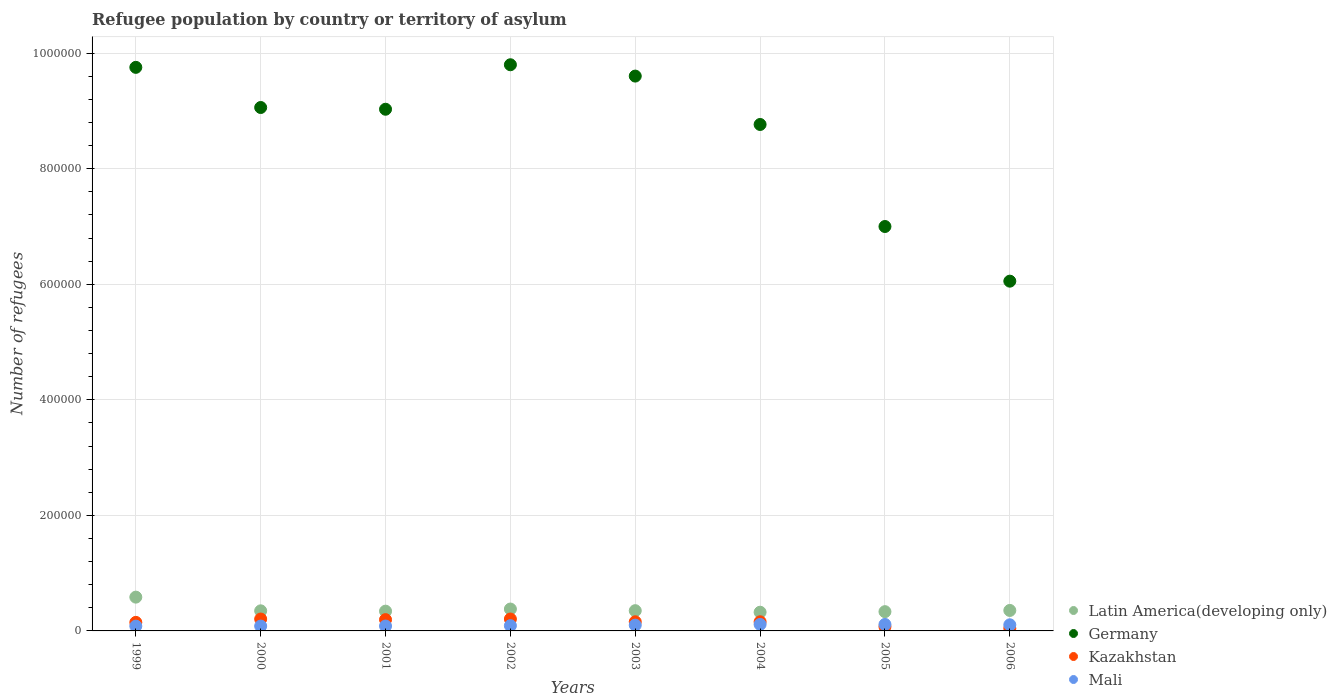How many different coloured dotlines are there?
Offer a very short reply. 4. What is the number of refugees in Germany in 2001?
Your answer should be compact. 9.03e+05. Across all years, what is the maximum number of refugees in Germany?
Your answer should be very brief. 9.80e+05. Across all years, what is the minimum number of refugees in Mali?
Ensure brevity in your answer.  8302. In which year was the number of refugees in Germany maximum?
Offer a very short reply. 2002. In which year was the number of refugees in Kazakhstan minimum?
Make the answer very short. 2006. What is the total number of refugees in Mali in the graph?
Keep it short and to the point. 7.73e+04. What is the difference between the number of refugees in Kazakhstan in 1999 and that in 2005?
Your answer should be very brief. 7530. What is the difference between the number of refugees in Latin America(developing only) in 2004 and the number of refugees in Germany in 2005?
Offer a very short reply. -6.68e+05. What is the average number of refugees in Kazakhstan per year?
Your answer should be very brief. 1.49e+04. In the year 2005, what is the difference between the number of refugees in Kazakhstan and number of refugees in Germany?
Provide a succinct answer. -6.93e+05. In how many years, is the number of refugees in Latin America(developing only) greater than 720000?
Your response must be concise. 0. What is the ratio of the number of refugees in Latin America(developing only) in 2002 to that in 2006?
Offer a terse response. 1.07. Is the number of refugees in Mali in 2002 less than that in 2006?
Ensure brevity in your answer.  Yes. Is the difference between the number of refugees in Kazakhstan in 1999 and 2006 greater than the difference between the number of refugees in Germany in 1999 and 2006?
Keep it short and to the point. No. What is the difference between the highest and the second highest number of refugees in Latin America(developing only)?
Provide a short and direct response. 2.06e+04. What is the difference between the highest and the lowest number of refugees in Germany?
Offer a terse response. 3.75e+05. Is it the case that in every year, the sum of the number of refugees in Germany and number of refugees in Mali  is greater than the sum of number of refugees in Kazakhstan and number of refugees in Latin America(developing only)?
Your answer should be compact. No. Is it the case that in every year, the sum of the number of refugees in Mali and number of refugees in Germany  is greater than the number of refugees in Latin America(developing only)?
Your answer should be compact. Yes. Does the number of refugees in Mali monotonically increase over the years?
Provide a succinct answer. No. Is the number of refugees in Latin America(developing only) strictly less than the number of refugees in Kazakhstan over the years?
Your answer should be compact. No. What is the difference between two consecutive major ticks on the Y-axis?
Provide a short and direct response. 2.00e+05. Are the values on the major ticks of Y-axis written in scientific E-notation?
Offer a terse response. No. How many legend labels are there?
Ensure brevity in your answer.  4. What is the title of the graph?
Provide a succinct answer. Refugee population by country or territory of asylum. Does "St. Kitts and Nevis" appear as one of the legend labels in the graph?
Ensure brevity in your answer.  No. What is the label or title of the X-axis?
Provide a succinct answer. Years. What is the label or title of the Y-axis?
Provide a succinct answer. Number of refugees. What is the Number of refugees of Latin America(developing only) in 1999?
Your response must be concise. 5.85e+04. What is the Number of refugees in Germany in 1999?
Provide a succinct answer. 9.76e+05. What is the Number of refugees of Kazakhstan in 1999?
Give a very brief answer. 1.48e+04. What is the Number of refugees of Mali in 1999?
Provide a succinct answer. 8302. What is the Number of refugees of Latin America(developing only) in 2000?
Your answer should be very brief. 3.48e+04. What is the Number of refugees of Germany in 2000?
Your answer should be compact. 9.06e+05. What is the Number of refugees in Kazakhstan in 2000?
Make the answer very short. 2.06e+04. What is the Number of refugees of Mali in 2000?
Offer a very short reply. 8412. What is the Number of refugees of Latin America(developing only) in 2001?
Ensure brevity in your answer.  3.42e+04. What is the Number of refugees of Germany in 2001?
Offer a very short reply. 9.03e+05. What is the Number of refugees of Kazakhstan in 2001?
Your answer should be compact. 1.95e+04. What is the Number of refugees in Mali in 2001?
Your response must be concise. 8439. What is the Number of refugees in Latin America(developing only) in 2002?
Your answer should be very brief. 3.79e+04. What is the Number of refugees in Germany in 2002?
Offer a very short reply. 9.80e+05. What is the Number of refugees in Kazakhstan in 2002?
Offer a very short reply. 2.06e+04. What is the Number of refugees of Mali in 2002?
Keep it short and to the point. 9095. What is the Number of refugees of Latin America(developing only) in 2003?
Provide a short and direct response. 3.50e+04. What is the Number of refugees of Germany in 2003?
Ensure brevity in your answer.  9.60e+05. What is the Number of refugees of Kazakhstan in 2003?
Provide a short and direct response. 1.58e+04. What is the Number of refugees in Mali in 2003?
Your answer should be very brief. 1.00e+04. What is the Number of refugees of Latin America(developing only) in 2004?
Keep it short and to the point. 3.24e+04. What is the Number of refugees of Germany in 2004?
Offer a terse response. 8.77e+05. What is the Number of refugees in Kazakhstan in 2004?
Keep it short and to the point. 1.58e+04. What is the Number of refugees in Mali in 2004?
Provide a short and direct response. 1.13e+04. What is the Number of refugees of Latin America(developing only) in 2005?
Give a very brief answer. 3.33e+04. What is the Number of refugees in Germany in 2005?
Ensure brevity in your answer.  7.00e+05. What is the Number of refugees in Kazakhstan in 2005?
Offer a very short reply. 7265. What is the Number of refugees in Mali in 2005?
Make the answer very short. 1.12e+04. What is the Number of refugees in Latin America(developing only) in 2006?
Make the answer very short. 3.54e+04. What is the Number of refugees in Germany in 2006?
Offer a terse response. 6.05e+05. What is the Number of refugees of Kazakhstan in 2006?
Provide a succinct answer. 4412. What is the Number of refugees in Mali in 2006?
Your answer should be compact. 1.06e+04. Across all years, what is the maximum Number of refugees of Latin America(developing only)?
Offer a terse response. 5.85e+04. Across all years, what is the maximum Number of refugees in Germany?
Provide a succinct answer. 9.80e+05. Across all years, what is the maximum Number of refugees of Kazakhstan?
Your answer should be compact. 2.06e+04. Across all years, what is the maximum Number of refugees in Mali?
Make the answer very short. 1.13e+04. Across all years, what is the minimum Number of refugees of Latin America(developing only)?
Provide a short and direct response. 3.24e+04. Across all years, what is the minimum Number of refugees of Germany?
Your answer should be compact. 6.05e+05. Across all years, what is the minimum Number of refugees in Kazakhstan?
Provide a succinct answer. 4412. Across all years, what is the minimum Number of refugees in Mali?
Offer a terse response. 8302. What is the total Number of refugees in Latin America(developing only) in the graph?
Keep it short and to the point. 3.02e+05. What is the total Number of refugees in Germany in the graph?
Ensure brevity in your answer.  6.91e+06. What is the total Number of refugees of Kazakhstan in the graph?
Provide a short and direct response. 1.19e+05. What is the total Number of refugees of Mali in the graph?
Give a very brief answer. 7.73e+04. What is the difference between the Number of refugees of Latin America(developing only) in 1999 and that in 2000?
Keep it short and to the point. 2.37e+04. What is the difference between the Number of refugees of Germany in 1999 and that in 2000?
Provide a succinct answer. 6.95e+04. What is the difference between the Number of refugees in Kazakhstan in 1999 and that in 2000?
Your response must be concise. -5779. What is the difference between the Number of refugees of Mali in 1999 and that in 2000?
Your answer should be compact. -110. What is the difference between the Number of refugees in Latin America(developing only) in 1999 and that in 2001?
Give a very brief answer. 2.43e+04. What is the difference between the Number of refugees in Germany in 1999 and that in 2001?
Offer a very short reply. 7.25e+04. What is the difference between the Number of refugees of Kazakhstan in 1999 and that in 2001?
Make the answer very short. -4736. What is the difference between the Number of refugees in Mali in 1999 and that in 2001?
Provide a short and direct response. -137. What is the difference between the Number of refugees in Latin America(developing only) in 1999 and that in 2002?
Provide a short and direct response. 2.06e+04. What is the difference between the Number of refugees in Germany in 1999 and that in 2002?
Give a very brief answer. -4500. What is the difference between the Number of refugees in Kazakhstan in 1999 and that in 2002?
Make the answer very short. -5815. What is the difference between the Number of refugees of Mali in 1999 and that in 2002?
Provide a short and direct response. -793. What is the difference between the Number of refugees in Latin America(developing only) in 1999 and that in 2003?
Ensure brevity in your answer.  2.34e+04. What is the difference between the Number of refugees of Germany in 1999 and that in 2003?
Offer a terse response. 1.51e+04. What is the difference between the Number of refugees of Kazakhstan in 1999 and that in 2003?
Your answer should be compact. -1036. What is the difference between the Number of refugees in Mali in 1999 and that in 2003?
Your answer should be compact. -1707. What is the difference between the Number of refugees of Latin America(developing only) in 1999 and that in 2004?
Make the answer very short. 2.61e+04. What is the difference between the Number of refugees of Germany in 1999 and that in 2004?
Keep it short and to the point. 9.89e+04. What is the difference between the Number of refugees in Kazakhstan in 1999 and that in 2004?
Your response must be concise. -1049. What is the difference between the Number of refugees of Mali in 1999 and that in 2004?
Your answer should be compact. -2954. What is the difference between the Number of refugees of Latin America(developing only) in 1999 and that in 2005?
Provide a short and direct response. 2.51e+04. What is the difference between the Number of refugees in Germany in 1999 and that in 2005?
Offer a very short reply. 2.75e+05. What is the difference between the Number of refugees in Kazakhstan in 1999 and that in 2005?
Offer a terse response. 7530. What is the difference between the Number of refugees in Mali in 1999 and that in 2005?
Your answer should be very brief. -2931. What is the difference between the Number of refugees of Latin America(developing only) in 1999 and that in 2006?
Make the answer very short. 2.30e+04. What is the difference between the Number of refugees in Germany in 1999 and that in 2006?
Your response must be concise. 3.70e+05. What is the difference between the Number of refugees in Kazakhstan in 1999 and that in 2006?
Keep it short and to the point. 1.04e+04. What is the difference between the Number of refugees in Mali in 1999 and that in 2006?
Offer a very short reply. -2283. What is the difference between the Number of refugees of Latin America(developing only) in 2000 and that in 2001?
Offer a terse response. 583. What is the difference between the Number of refugees in Germany in 2000 and that in 2001?
Provide a short and direct response. 3000. What is the difference between the Number of refugees in Kazakhstan in 2000 and that in 2001?
Provide a succinct answer. 1043. What is the difference between the Number of refugees of Latin America(developing only) in 2000 and that in 2002?
Provide a short and direct response. -3089. What is the difference between the Number of refugees in Germany in 2000 and that in 2002?
Ensure brevity in your answer.  -7.40e+04. What is the difference between the Number of refugees in Kazakhstan in 2000 and that in 2002?
Give a very brief answer. -36. What is the difference between the Number of refugees in Mali in 2000 and that in 2002?
Make the answer very short. -683. What is the difference between the Number of refugees of Latin America(developing only) in 2000 and that in 2003?
Give a very brief answer. -262. What is the difference between the Number of refugees in Germany in 2000 and that in 2003?
Your answer should be very brief. -5.44e+04. What is the difference between the Number of refugees in Kazakhstan in 2000 and that in 2003?
Keep it short and to the point. 4743. What is the difference between the Number of refugees of Mali in 2000 and that in 2003?
Offer a very short reply. -1597. What is the difference between the Number of refugees in Latin America(developing only) in 2000 and that in 2004?
Your response must be concise. 2416. What is the difference between the Number of refugees of Germany in 2000 and that in 2004?
Offer a very short reply. 2.94e+04. What is the difference between the Number of refugees of Kazakhstan in 2000 and that in 2004?
Keep it short and to the point. 4730. What is the difference between the Number of refugees of Mali in 2000 and that in 2004?
Your response must be concise. -2844. What is the difference between the Number of refugees of Latin America(developing only) in 2000 and that in 2005?
Make the answer very short. 1440. What is the difference between the Number of refugees of Germany in 2000 and that in 2005?
Provide a succinct answer. 2.06e+05. What is the difference between the Number of refugees of Kazakhstan in 2000 and that in 2005?
Your answer should be compact. 1.33e+04. What is the difference between the Number of refugees of Mali in 2000 and that in 2005?
Your response must be concise. -2821. What is the difference between the Number of refugees of Latin America(developing only) in 2000 and that in 2006?
Offer a terse response. -660. What is the difference between the Number of refugees in Germany in 2000 and that in 2006?
Make the answer very short. 3.01e+05. What is the difference between the Number of refugees in Kazakhstan in 2000 and that in 2006?
Provide a succinct answer. 1.62e+04. What is the difference between the Number of refugees in Mali in 2000 and that in 2006?
Keep it short and to the point. -2173. What is the difference between the Number of refugees of Latin America(developing only) in 2001 and that in 2002?
Keep it short and to the point. -3672. What is the difference between the Number of refugees in Germany in 2001 and that in 2002?
Provide a succinct answer. -7.70e+04. What is the difference between the Number of refugees of Kazakhstan in 2001 and that in 2002?
Your answer should be very brief. -1079. What is the difference between the Number of refugees in Mali in 2001 and that in 2002?
Give a very brief answer. -656. What is the difference between the Number of refugees of Latin America(developing only) in 2001 and that in 2003?
Make the answer very short. -845. What is the difference between the Number of refugees of Germany in 2001 and that in 2003?
Your answer should be compact. -5.74e+04. What is the difference between the Number of refugees of Kazakhstan in 2001 and that in 2003?
Keep it short and to the point. 3700. What is the difference between the Number of refugees of Mali in 2001 and that in 2003?
Offer a very short reply. -1570. What is the difference between the Number of refugees in Latin America(developing only) in 2001 and that in 2004?
Provide a short and direct response. 1833. What is the difference between the Number of refugees in Germany in 2001 and that in 2004?
Offer a very short reply. 2.64e+04. What is the difference between the Number of refugees in Kazakhstan in 2001 and that in 2004?
Provide a succinct answer. 3687. What is the difference between the Number of refugees of Mali in 2001 and that in 2004?
Your response must be concise. -2817. What is the difference between the Number of refugees of Latin America(developing only) in 2001 and that in 2005?
Offer a terse response. 857. What is the difference between the Number of refugees of Germany in 2001 and that in 2005?
Your answer should be compact. 2.03e+05. What is the difference between the Number of refugees of Kazakhstan in 2001 and that in 2005?
Ensure brevity in your answer.  1.23e+04. What is the difference between the Number of refugees of Mali in 2001 and that in 2005?
Keep it short and to the point. -2794. What is the difference between the Number of refugees of Latin America(developing only) in 2001 and that in 2006?
Ensure brevity in your answer.  -1243. What is the difference between the Number of refugees in Germany in 2001 and that in 2006?
Make the answer very short. 2.98e+05. What is the difference between the Number of refugees in Kazakhstan in 2001 and that in 2006?
Your response must be concise. 1.51e+04. What is the difference between the Number of refugees in Mali in 2001 and that in 2006?
Provide a succinct answer. -2146. What is the difference between the Number of refugees in Latin America(developing only) in 2002 and that in 2003?
Offer a terse response. 2827. What is the difference between the Number of refugees of Germany in 2002 and that in 2003?
Your answer should be compact. 1.96e+04. What is the difference between the Number of refugees in Kazakhstan in 2002 and that in 2003?
Provide a short and direct response. 4779. What is the difference between the Number of refugees in Mali in 2002 and that in 2003?
Provide a succinct answer. -914. What is the difference between the Number of refugees of Latin America(developing only) in 2002 and that in 2004?
Ensure brevity in your answer.  5505. What is the difference between the Number of refugees in Germany in 2002 and that in 2004?
Provide a short and direct response. 1.03e+05. What is the difference between the Number of refugees of Kazakhstan in 2002 and that in 2004?
Provide a short and direct response. 4766. What is the difference between the Number of refugees of Mali in 2002 and that in 2004?
Your answer should be very brief. -2161. What is the difference between the Number of refugees of Latin America(developing only) in 2002 and that in 2005?
Your response must be concise. 4529. What is the difference between the Number of refugees in Germany in 2002 and that in 2005?
Ensure brevity in your answer.  2.80e+05. What is the difference between the Number of refugees in Kazakhstan in 2002 and that in 2005?
Make the answer very short. 1.33e+04. What is the difference between the Number of refugees of Mali in 2002 and that in 2005?
Provide a short and direct response. -2138. What is the difference between the Number of refugees in Latin America(developing only) in 2002 and that in 2006?
Offer a terse response. 2429. What is the difference between the Number of refugees in Germany in 2002 and that in 2006?
Ensure brevity in your answer.  3.75e+05. What is the difference between the Number of refugees in Kazakhstan in 2002 and that in 2006?
Provide a short and direct response. 1.62e+04. What is the difference between the Number of refugees in Mali in 2002 and that in 2006?
Make the answer very short. -1490. What is the difference between the Number of refugees in Latin America(developing only) in 2003 and that in 2004?
Ensure brevity in your answer.  2678. What is the difference between the Number of refugees of Germany in 2003 and that in 2004?
Your answer should be very brief. 8.38e+04. What is the difference between the Number of refugees of Mali in 2003 and that in 2004?
Offer a terse response. -1247. What is the difference between the Number of refugees of Latin America(developing only) in 2003 and that in 2005?
Provide a succinct answer. 1702. What is the difference between the Number of refugees in Germany in 2003 and that in 2005?
Provide a short and direct response. 2.60e+05. What is the difference between the Number of refugees of Kazakhstan in 2003 and that in 2005?
Ensure brevity in your answer.  8566. What is the difference between the Number of refugees of Mali in 2003 and that in 2005?
Ensure brevity in your answer.  -1224. What is the difference between the Number of refugees of Latin America(developing only) in 2003 and that in 2006?
Your answer should be very brief. -398. What is the difference between the Number of refugees in Germany in 2003 and that in 2006?
Ensure brevity in your answer.  3.55e+05. What is the difference between the Number of refugees in Kazakhstan in 2003 and that in 2006?
Offer a terse response. 1.14e+04. What is the difference between the Number of refugees in Mali in 2003 and that in 2006?
Your response must be concise. -576. What is the difference between the Number of refugees in Latin America(developing only) in 2004 and that in 2005?
Offer a terse response. -976. What is the difference between the Number of refugees of Germany in 2004 and that in 2005?
Offer a terse response. 1.77e+05. What is the difference between the Number of refugees in Kazakhstan in 2004 and that in 2005?
Offer a very short reply. 8579. What is the difference between the Number of refugees in Latin America(developing only) in 2004 and that in 2006?
Provide a short and direct response. -3076. What is the difference between the Number of refugees in Germany in 2004 and that in 2006?
Provide a short and direct response. 2.71e+05. What is the difference between the Number of refugees in Kazakhstan in 2004 and that in 2006?
Offer a terse response. 1.14e+04. What is the difference between the Number of refugees in Mali in 2004 and that in 2006?
Offer a terse response. 671. What is the difference between the Number of refugees of Latin America(developing only) in 2005 and that in 2006?
Offer a terse response. -2100. What is the difference between the Number of refugees of Germany in 2005 and that in 2006?
Make the answer very short. 9.46e+04. What is the difference between the Number of refugees of Kazakhstan in 2005 and that in 2006?
Your answer should be very brief. 2853. What is the difference between the Number of refugees of Mali in 2005 and that in 2006?
Give a very brief answer. 648. What is the difference between the Number of refugees in Latin America(developing only) in 1999 and the Number of refugees in Germany in 2000?
Your response must be concise. -8.48e+05. What is the difference between the Number of refugees in Latin America(developing only) in 1999 and the Number of refugees in Kazakhstan in 2000?
Provide a succinct answer. 3.79e+04. What is the difference between the Number of refugees in Latin America(developing only) in 1999 and the Number of refugees in Mali in 2000?
Provide a succinct answer. 5.01e+04. What is the difference between the Number of refugees in Germany in 1999 and the Number of refugees in Kazakhstan in 2000?
Keep it short and to the point. 9.55e+05. What is the difference between the Number of refugees in Germany in 1999 and the Number of refugees in Mali in 2000?
Provide a succinct answer. 9.67e+05. What is the difference between the Number of refugees in Kazakhstan in 1999 and the Number of refugees in Mali in 2000?
Provide a short and direct response. 6383. What is the difference between the Number of refugees of Latin America(developing only) in 1999 and the Number of refugees of Germany in 2001?
Your response must be concise. -8.45e+05. What is the difference between the Number of refugees in Latin America(developing only) in 1999 and the Number of refugees in Kazakhstan in 2001?
Your answer should be very brief. 3.90e+04. What is the difference between the Number of refugees of Latin America(developing only) in 1999 and the Number of refugees of Mali in 2001?
Provide a short and direct response. 5.00e+04. What is the difference between the Number of refugees of Germany in 1999 and the Number of refugees of Kazakhstan in 2001?
Provide a short and direct response. 9.56e+05. What is the difference between the Number of refugees in Germany in 1999 and the Number of refugees in Mali in 2001?
Offer a terse response. 9.67e+05. What is the difference between the Number of refugees in Kazakhstan in 1999 and the Number of refugees in Mali in 2001?
Provide a short and direct response. 6356. What is the difference between the Number of refugees in Latin America(developing only) in 1999 and the Number of refugees in Germany in 2002?
Make the answer very short. -9.22e+05. What is the difference between the Number of refugees in Latin America(developing only) in 1999 and the Number of refugees in Kazakhstan in 2002?
Your response must be concise. 3.79e+04. What is the difference between the Number of refugees of Latin America(developing only) in 1999 and the Number of refugees of Mali in 2002?
Offer a terse response. 4.94e+04. What is the difference between the Number of refugees in Germany in 1999 and the Number of refugees in Kazakhstan in 2002?
Keep it short and to the point. 9.55e+05. What is the difference between the Number of refugees of Germany in 1999 and the Number of refugees of Mali in 2002?
Your answer should be compact. 9.66e+05. What is the difference between the Number of refugees in Kazakhstan in 1999 and the Number of refugees in Mali in 2002?
Your answer should be very brief. 5700. What is the difference between the Number of refugees of Latin America(developing only) in 1999 and the Number of refugees of Germany in 2003?
Your answer should be compact. -9.02e+05. What is the difference between the Number of refugees of Latin America(developing only) in 1999 and the Number of refugees of Kazakhstan in 2003?
Ensure brevity in your answer.  4.27e+04. What is the difference between the Number of refugees of Latin America(developing only) in 1999 and the Number of refugees of Mali in 2003?
Your response must be concise. 4.85e+04. What is the difference between the Number of refugees in Germany in 1999 and the Number of refugees in Kazakhstan in 2003?
Provide a succinct answer. 9.60e+05. What is the difference between the Number of refugees in Germany in 1999 and the Number of refugees in Mali in 2003?
Offer a terse response. 9.65e+05. What is the difference between the Number of refugees in Kazakhstan in 1999 and the Number of refugees in Mali in 2003?
Offer a very short reply. 4786. What is the difference between the Number of refugees of Latin America(developing only) in 1999 and the Number of refugees of Germany in 2004?
Provide a succinct answer. -8.18e+05. What is the difference between the Number of refugees of Latin America(developing only) in 1999 and the Number of refugees of Kazakhstan in 2004?
Your response must be concise. 4.26e+04. What is the difference between the Number of refugees in Latin America(developing only) in 1999 and the Number of refugees in Mali in 2004?
Provide a short and direct response. 4.72e+04. What is the difference between the Number of refugees of Germany in 1999 and the Number of refugees of Kazakhstan in 2004?
Your answer should be compact. 9.60e+05. What is the difference between the Number of refugees of Germany in 1999 and the Number of refugees of Mali in 2004?
Make the answer very short. 9.64e+05. What is the difference between the Number of refugees in Kazakhstan in 1999 and the Number of refugees in Mali in 2004?
Ensure brevity in your answer.  3539. What is the difference between the Number of refugees in Latin America(developing only) in 1999 and the Number of refugees in Germany in 2005?
Your response must be concise. -6.42e+05. What is the difference between the Number of refugees of Latin America(developing only) in 1999 and the Number of refugees of Kazakhstan in 2005?
Your answer should be very brief. 5.12e+04. What is the difference between the Number of refugees of Latin America(developing only) in 1999 and the Number of refugees of Mali in 2005?
Provide a succinct answer. 4.73e+04. What is the difference between the Number of refugees of Germany in 1999 and the Number of refugees of Kazakhstan in 2005?
Your answer should be very brief. 9.68e+05. What is the difference between the Number of refugees in Germany in 1999 and the Number of refugees in Mali in 2005?
Your response must be concise. 9.64e+05. What is the difference between the Number of refugees in Kazakhstan in 1999 and the Number of refugees in Mali in 2005?
Offer a very short reply. 3562. What is the difference between the Number of refugees in Latin America(developing only) in 1999 and the Number of refugees in Germany in 2006?
Your answer should be compact. -5.47e+05. What is the difference between the Number of refugees in Latin America(developing only) in 1999 and the Number of refugees in Kazakhstan in 2006?
Give a very brief answer. 5.41e+04. What is the difference between the Number of refugees of Latin America(developing only) in 1999 and the Number of refugees of Mali in 2006?
Make the answer very short. 4.79e+04. What is the difference between the Number of refugees of Germany in 1999 and the Number of refugees of Kazakhstan in 2006?
Keep it short and to the point. 9.71e+05. What is the difference between the Number of refugees in Germany in 1999 and the Number of refugees in Mali in 2006?
Keep it short and to the point. 9.65e+05. What is the difference between the Number of refugees of Kazakhstan in 1999 and the Number of refugees of Mali in 2006?
Offer a very short reply. 4210. What is the difference between the Number of refugees of Latin America(developing only) in 2000 and the Number of refugees of Germany in 2001?
Ensure brevity in your answer.  -8.68e+05. What is the difference between the Number of refugees of Latin America(developing only) in 2000 and the Number of refugees of Kazakhstan in 2001?
Your response must be concise. 1.52e+04. What is the difference between the Number of refugees in Latin America(developing only) in 2000 and the Number of refugees in Mali in 2001?
Offer a terse response. 2.63e+04. What is the difference between the Number of refugees of Germany in 2000 and the Number of refugees of Kazakhstan in 2001?
Your answer should be compact. 8.86e+05. What is the difference between the Number of refugees in Germany in 2000 and the Number of refugees in Mali in 2001?
Ensure brevity in your answer.  8.98e+05. What is the difference between the Number of refugees in Kazakhstan in 2000 and the Number of refugees in Mali in 2001?
Your answer should be very brief. 1.21e+04. What is the difference between the Number of refugees in Latin America(developing only) in 2000 and the Number of refugees in Germany in 2002?
Give a very brief answer. -9.45e+05. What is the difference between the Number of refugees of Latin America(developing only) in 2000 and the Number of refugees of Kazakhstan in 2002?
Make the answer very short. 1.42e+04. What is the difference between the Number of refugees of Latin America(developing only) in 2000 and the Number of refugees of Mali in 2002?
Provide a succinct answer. 2.57e+04. What is the difference between the Number of refugees of Germany in 2000 and the Number of refugees of Kazakhstan in 2002?
Keep it short and to the point. 8.85e+05. What is the difference between the Number of refugees in Germany in 2000 and the Number of refugees in Mali in 2002?
Provide a succinct answer. 8.97e+05. What is the difference between the Number of refugees in Kazakhstan in 2000 and the Number of refugees in Mali in 2002?
Make the answer very short. 1.15e+04. What is the difference between the Number of refugees in Latin America(developing only) in 2000 and the Number of refugees in Germany in 2003?
Offer a terse response. -9.26e+05. What is the difference between the Number of refugees in Latin America(developing only) in 2000 and the Number of refugees in Kazakhstan in 2003?
Offer a terse response. 1.89e+04. What is the difference between the Number of refugees of Latin America(developing only) in 2000 and the Number of refugees of Mali in 2003?
Your answer should be very brief. 2.48e+04. What is the difference between the Number of refugees in Germany in 2000 and the Number of refugees in Kazakhstan in 2003?
Keep it short and to the point. 8.90e+05. What is the difference between the Number of refugees in Germany in 2000 and the Number of refugees in Mali in 2003?
Offer a terse response. 8.96e+05. What is the difference between the Number of refugees of Kazakhstan in 2000 and the Number of refugees of Mali in 2003?
Make the answer very short. 1.06e+04. What is the difference between the Number of refugees in Latin America(developing only) in 2000 and the Number of refugees in Germany in 2004?
Your answer should be compact. -8.42e+05. What is the difference between the Number of refugees of Latin America(developing only) in 2000 and the Number of refugees of Kazakhstan in 2004?
Your answer should be compact. 1.89e+04. What is the difference between the Number of refugees of Latin America(developing only) in 2000 and the Number of refugees of Mali in 2004?
Give a very brief answer. 2.35e+04. What is the difference between the Number of refugees in Germany in 2000 and the Number of refugees in Kazakhstan in 2004?
Provide a succinct answer. 8.90e+05. What is the difference between the Number of refugees in Germany in 2000 and the Number of refugees in Mali in 2004?
Keep it short and to the point. 8.95e+05. What is the difference between the Number of refugees of Kazakhstan in 2000 and the Number of refugees of Mali in 2004?
Provide a short and direct response. 9318. What is the difference between the Number of refugees of Latin America(developing only) in 2000 and the Number of refugees of Germany in 2005?
Your answer should be compact. -6.65e+05. What is the difference between the Number of refugees in Latin America(developing only) in 2000 and the Number of refugees in Kazakhstan in 2005?
Give a very brief answer. 2.75e+04. What is the difference between the Number of refugees in Latin America(developing only) in 2000 and the Number of refugees in Mali in 2005?
Provide a short and direct response. 2.35e+04. What is the difference between the Number of refugees of Germany in 2000 and the Number of refugees of Kazakhstan in 2005?
Keep it short and to the point. 8.99e+05. What is the difference between the Number of refugees in Germany in 2000 and the Number of refugees in Mali in 2005?
Your response must be concise. 8.95e+05. What is the difference between the Number of refugees of Kazakhstan in 2000 and the Number of refugees of Mali in 2005?
Your response must be concise. 9341. What is the difference between the Number of refugees of Latin America(developing only) in 2000 and the Number of refugees of Germany in 2006?
Offer a terse response. -5.71e+05. What is the difference between the Number of refugees in Latin America(developing only) in 2000 and the Number of refugees in Kazakhstan in 2006?
Give a very brief answer. 3.04e+04. What is the difference between the Number of refugees in Latin America(developing only) in 2000 and the Number of refugees in Mali in 2006?
Offer a terse response. 2.42e+04. What is the difference between the Number of refugees of Germany in 2000 and the Number of refugees of Kazakhstan in 2006?
Your answer should be very brief. 9.02e+05. What is the difference between the Number of refugees of Germany in 2000 and the Number of refugees of Mali in 2006?
Make the answer very short. 8.95e+05. What is the difference between the Number of refugees in Kazakhstan in 2000 and the Number of refugees in Mali in 2006?
Your answer should be compact. 9989. What is the difference between the Number of refugees in Latin America(developing only) in 2001 and the Number of refugees in Germany in 2002?
Give a very brief answer. -9.46e+05. What is the difference between the Number of refugees of Latin America(developing only) in 2001 and the Number of refugees of Kazakhstan in 2002?
Provide a short and direct response. 1.36e+04. What is the difference between the Number of refugees in Latin America(developing only) in 2001 and the Number of refugees in Mali in 2002?
Offer a very short reply. 2.51e+04. What is the difference between the Number of refugees of Germany in 2001 and the Number of refugees of Kazakhstan in 2002?
Keep it short and to the point. 8.82e+05. What is the difference between the Number of refugees of Germany in 2001 and the Number of refugees of Mali in 2002?
Give a very brief answer. 8.94e+05. What is the difference between the Number of refugees in Kazakhstan in 2001 and the Number of refugees in Mali in 2002?
Your answer should be very brief. 1.04e+04. What is the difference between the Number of refugees of Latin America(developing only) in 2001 and the Number of refugees of Germany in 2003?
Your answer should be compact. -9.26e+05. What is the difference between the Number of refugees in Latin America(developing only) in 2001 and the Number of refugees in Kazakhstan in 2003?
Keep it short and to the point. 1.84e+04. What is the difference between the Number of refugees in Latin America(developing only) in 2001 and the Number of refugees in Mali in 2003?
Offer a very short reply. 2.42e+04. What is the difference between the Number of refugees in Germany in 2001 and the Number of refugees in Kazakhstan in 2003?
Offer a very short reply. 8.87e+05. What is the difference between the Number of refugees in Germany in 2001 and the Number of refugees in Mali in 2003?
Make the answer very short. 8.93e+05. What is the difference between the Number of refugees of Kazakhstan in 2001 and the Number of refugees of Mali in 2003?
Your answer should be very brief. 9522. What is the difference between the Number of refugees in Latin America(developing only) in 2001 and the Number of refugees in Germany in 2004?
Your answer should be very brief. -8.42e+05. What is the difference between the Number of refugees in Latin America(developing only) in 2001 and the Number of refugees in Kazakhstan in 2004?
Your answer should be very brief. 1.84e+04. What is the difference between the Number of refugees in Latin America(developing only) in 2001 and the Number of refugees in Mali in 2004?
Keep it short and to the point. 2.29e+04. What is the difference between the Number of refugees of Germany in 2001 and the Number of refugees of Kazakhstan in 2004?
Provide a succinct answer. 8.87e+05. What is the difference between the Number of refugees of Germany in 2001 and the Number of refugees of Mali in 2004?
Provide a succinct answer. 8.92e+05. What is the difference between the Number of refugees in Kazakhstan in 2001 and the Number of refugees in Mali in 2004?
Give a very brief answer. 8275. What is the difference between the Number of refugees in Latin America(developing only) in 2001 and the Number of refugees in Germany in 2005?
Ensure brevity in your answer.  -6.66e+05. What is the difference between the Number of refugees in Latin America(developing only) in 2001 and the Number of refugees in Kazakhstan in 2005?
Your response must be concise. 2.69e+04. What is the difference between the Number of refugees in Latin America(developing only) in 2001 and the Number of refugees in Mali in 2005?
Provide a short and direct response. 2.30e+04. What is the difference between the Number of refugees of Germany in 2001 and the Number of refugees of Kazakhstan in 2005?
Give a very brief answer. 8.96e+05. What is the difference between the Number of refugees in Germany in 2001 and the Number of refugees in Mali in 2005?
Make the answer very short. 8.92e+05. What is the difference between the Number of refugees of Kazakhstan in 2001 and the Number of refugees of Mali in 2005?
Offer a terse response. 8298. What is the difference between the Number of refugees in Latin America(developing only) in 2001 and the Number of refugees in Germany in 2006?
Ensure brevity in your answer.  -5.71e+05. What is the difference between the Number of refugees in Latin America(developing only) in 2001 and the Number of refugees in Kazakhstan in 2006?
Ensure brevity in your answer.  2.98e+04. What is the difference between the Number of refugees of Latin America(developing only) in 2001 and the Number of refugees of Mali in 2006?
Offer a very short reply. 2.36e+04. What is the difference between the Number of refugees of Germany in 2001 and the Number of refugees of Kazakhstan in 2006?
Your answer should be very brief. 8.99e+05. What is the difference between the Number of refugees of Germany in 2001 and the Number of refugees of Mali in 2006?
Your answer should be compact. 8.92e+05. What is the difference between the Number of refugees in Kazakhstan in 2001 and the Number of refugees in Mali in 2006?
Your response must be concise. 8946. What is the difference between the Number of refugees of Latin America(developing only) in 2002 and the Number of refugees of Germany in 2003?
Your answer should be compact. -9.23e+05. What is the difference between the Number of refugees of Latin America(developing only) in 2002 and the Number of refugees of Kazakhstan in 2003?
Offer a very short reply. 2.20e+04. What is the difference between the Number of refugees in Latin America(developing only) in 2002 and the Number of refugees in Mali in 2003?
Offer a very short reply. 2.79e+04. What is the difference between the Number of refugees of Germany in 2002 and the Number of refugees of Kazakhstan in 2003?
Offer a terse response. 9.64e+05. What is the difference between the Number of refugees in Germany in 2002 and the Number of refugees in Mali in 2003?
Your answer should be compact. 9.70e+05. What is the difference between the Number of refugees of Kazakhstan in 2002 and the Number of refugees of Mali in 2003?
Your answer should be very brief. 1.06e+04. What is the difference between the Number of refugees of Latin America(developing only) in 2002 and the Number of refugees of Germany in 2004?
Ensure brevity in your answer.  -8.39e+05. What is the difference between the Number of refugees in Latin America(developing only) in 2002 and the Number of refugees in Kazakhstan in 2004?
Your answer should be compact. 2.20e+04. What is the difference between the Number of refugees of Latin America(developing only) in 2002 and the Number of refugees of Mali in 2004?
Ensure brevity in your answer.  2.66e+04. What is the difference between the Number of refugees of Germany in 2002 and the Number of refugees of Kazakhstan in 2004?
Your response must be concise. 9.64e+05. What is the difference between the Number of refugees of Germany in 2002 and the Number of refugees of Mali in 2004?
Ensure brevity in your answer.  9.69e+05. What is the difference between the Number of refugees in Kazakhstan in 2002 and the Number of refugees in Mali in 2004?
Provide a short and direct response. 9354. What is the difference between the Number of refugees of Latin America(developing only) in 2002 and the Number of refugees of Germany in 2005?
Offer a terse response. -6.62e+05. What is the difference between the Number of refugees of Latin America(developing only) in 2002 and the Number of refugees of Kazakhstan in 2005?
Your answer should be very brief. 3.06e+04. What is the difference between the Number of refugees in Latin America(developing only) in 2002 and the Number of refugees in Mali in 2005?
Your answer should be very brief. 2.66e+04. What is the difference between the Number of refugees in Germany in 2002 and the Number of refugees in Kazakhstan in 2005?
Ensure brevity in your answer.  9.73e+05. What is the difference between the Number of refugees in Germany in 2002 and the Number of refugees in Mali in 2005?
Give a very brief answer. 9.69e+05. What is the difference between the Number of refugees of Kazakhstan in 2002 and the Number of refugees of Mali in 2005?
Your answer should be very brief. 9377. What is the difference between the Number of refugees in Latin America(developing only) in 2002 and the Number of refugees in Germany in 2006?
Keep it short and to the point. -5.68e+05. What is the difference between the Number of refugees in Latin America(developing only) in 2002 and the Number of refugees in Kazakhstan in 2006?
Ensure brevity in your answer.  3.35e+04. What is the difference between the Number of refugees of Latin America(developing only) in 2002 and the Number of refugees of Mali in 2006?
Offer a very short reply. 2.73e+04. What is the difference between the Number of refugees in Germany in 2002 and the Number of refugees in Kazakhstan in 2006?
Offer a very short reply. 9.76e+05. What is the difference between the Number of refugees of Germany in 2002 and the Number of refugees of Mali in 2006?
Your answer should be compact. 9.69e+05. What is the difference between the Number of refugees in Kazakhstan in 2002 and the Number of refugees in Mali in 2006?
Provide a succinct answer. 1.00e+04. What is the difference between the Number of refugees in Latin America(developing only) in 2003 and the Number of refugees in Germany in 2004?
Offer a terse response. -8.42e+05. What is the difference between the Number of refugees of Latin America(developing only) in 2003 and the Number of refugees of Kazakhstan in 2004?
Provide a short and direct response. 1.92e+04. What is the difference between the Number of refugees of Latin America(developing only) in 2003 and the Number of refugees of Mali in 2004?
Make the answer very short. 2.38e+04. What is the difference between the Number of refugees of Germany in 2003 and the Number of refugees of Kazakhstan in 2004?
Your response must be concise. 9.45e+05. What is the difference between the Number of refugees of Germany in 2003 and the Number of refugees of Mali in 2004?
Provide a short and direct response. 9.49e+05. What is the difference between the Number of refugees of Kazakhstan in 2003 and the Number of refugees of Mali in 2004?
Provide a short and direct response. 4575. What is the difference between the Number of refugees in Latin America(developing only) in 2003 and the Number of refugees in Germany in 2005?
Offer a terse response. -6.65e+05. What is the difference between the Number of refugees of Latin America(developing only) in 2003 and the Number of refugees of Kazakhstan in 2005?
Provide a succinct answer. 2.78e+04. What is the difference between the Number of refugees in Latin America(developing only) in 2003 and the Number of refugees in Mali in 2005?
Your answer should be very brief. 2.38e+04. What is the difference between the Number of refugees in Germany in 2003 and the Number of refugees in Kazakhstan in 2005?
Offer a very short reply. 9.53e+05. What is the difference between the Number of refugees of Germany in 2003 and the Number of refugees of Mali in 2005?
Offer a very short reply. 9.49e+05. What is the difference between the Number of refugees in Kazakhstan in 2003 and the Number of refugees in Mali in 2005?
Offer a terse response. 4598. What is the difference between the Number of refugees in Latin America(developing only) in 2003 and the Number of refugees in Germany in 2006?
Keep it short and to the point. -5.70e+05. What is the difference between the Number of refugees in Latin America(developing only) in 2003 and the Number of refugees in Kazakhstan in 2006?
Keep it short and to the point. 3.06e+04. What is the difference between the Number of refugees of Latin America(developing only) in 2003 and the Number of refugees of Mali in 2006?
Provide a short and direct response. 2.45e+04. What is the difference between the Number of refugees of Germany in 2003 and the Number of refugees of Kazakhstan in 2006?
Offer a very short reply. 9.56e+05. What is the difference between the Number of refugees of Germany in 2003 and the Number of refugees of Mali in 2006?
Make the answer very short. 9.50e+05. What is the difference between the Number of refugees of Kazakhstan in 2003 and the Number of refugees of Mali in 2006?
Ensure brevity in your answer.  5246. What is the difference between the Number of refugees of Latin America(developing only) in 2004 and the Number of refugees of Germany in 2005?
Provide a succinct answer. -6.68e+05. What is the difference between the Number of refugees in Latin America(developing only) in 2004 and the Number of refugees in Kazakhstan in 2005?
Ensure brevity in your answer.  2.51e+04. What is the difference between the Number of refugees of Latin America(developing only) in 2004 and the Number of refugees of Mali in 2005?
Keep it short and to the point. 2.11e+04. What is the difference between the Number of refugees in Germany in 2004 and the Number of refugees in Kazakhstan in 2005?
Offer a terse response. 8.69e+05. What is the difference between the Number of refugees in Germany in 2004 and the Number of refugees in Mali in 2005?
Provide a succinct answer. 8.65e+05. What is the difference between the Number of refugees in Kazakhstan in 2004 and the Number of refugees in Mali in 2005?
Your answer should be very brief. 4611. What is the difference between the Number of refugees in Latin America(developing only) in 2004 and the Number of refugees in Germany in 2006?
Provide a succinct answer. -5.73e+05. What is the difference between the Number of refugees of Latin America(developing only) in 2004 and the Number of refugees of Kazakhstan in 2006?
Offer a terse response. 2.80e+04. What is the difference between the Number of refugees in Latin America(developing only) in 2004 and the Number of refugees in Mali in 2006?
Offer a very short reply. 2.18e+04. What is the difference between the Number of refugees of Germany in 2004 and the Number of refugees of Kazakhstan in 2006?
Provide a succinct answer. 8.72e+05. What is the difference between the Number of refugees of Germany in 2004 and the Number of refugees of Mali in 2006?
Provide a succinct answer. 8.66e+05. What is the difference between the Number of refugees of Kazakhstan in 2004 and the Number of refugees of Mali in 2006?
Give a very brief answer. 5259. What is the difference between the Number of refugees of Latin America(developing only) in 2005 and the Number of refugees of Germany in 2006?
Your answer should be very brief. -5.72e+05. What is the difference between the Number of refugees in Latin America(developing only) in 2005 and the Number of refugees in Kazakhstan in 2006?
Offer a very short reply. 2.89e+04. What is the difference between the Number of refugees in Latin America(developing only) in 2005 and the Number of refugees in Mali in 2006?
Offer a terse response. 2.28e+04. What is the difference between the Number of refugees in Germany in 2005 and the Number of refugees in Kazakhstan in 2006?
Ensure brevity in your answer.  6.96e+05. What is the difference between the Number of refugees in Germany in 2005 and the Number of refugees in Mali in 2006?
Provide a succinct answer. 6.89e+05. What is the difference between the Number of refugees in Kazakhstan in 2005 and the Number of refugees in Mali in 2006?
Give a very brief answer. -3320. What is the average Number of refugees of Latin America(developing only) per year?
Keep it short and to the point. 3.77e+04. What is the average Number of refugees in Germany per year?
Your answer should be compact. 8.63e+05. What is the average Number of refugees in Kazakhstan per year?
Keep it short and to the point. 1.49e+04. What is the average Number of refugees of Mali per year?
Offer a terse response. 9666.38. In the year 1999, what is the difference between the Number of refugees of Latin America(developing only) and Number of refugees of Germany?
Your answer should be compact. -9.17e+05. In the year 1999, what is the difference between the Number of refugees in Latin America(developing only) and Number of refugees in Kazakhstan?
Provide a succinct answer. 4.37e+04. In the year 1999, what is the difference between the Number of refugees of Latin America(developing only) and Number of refugees of Mali?
Your answer should be very brief. 5.02e+04. In the year 1999, what is the difference between the Number of refugees in Germany and Number of refugees in Kazakhstan?
Give a very brief answer. 9.61e+05. In the year 1999, what is the difference between the Number of refugees in Germany and Number of refugees in Mali?
Provide a short and direct response. 9.67e+05. In the year 1999, what is the difference between the Number of refugees of Kazakhstan and Number of refugees of Mali?
Provide a short and direct response. 6493. In the year 2000, what is the difference between the Number of refugees of Latin America(developing only) and Number of refugees of Germany?
Keep it short and to the point. -8.71e+05. In the year 2000, what is the difference between the Number of refugees of Latin America(developing only) and Number of refugees of Kazakhstan?
Ensure brevity in your answer.  1.42e+04. In the year 2000, what is the difference between the Number of refugees of Latin America(developing only) and Number of refugees of Mali?
Provide a succinct answer. 2.64e+04. In the year 2000, what is the difference between the Number of refugees of Germany and Number of refugees of Kazakhstan?
Your answer should be very brief. 8.85e+05. In the year 2000, what is the difference between the Number of refugees in Germany and Number of refugees in Mali?
Make the answer very short. 8.98e+05. In the year 2000, what is the difference between the Number of refugees in Kazakhstan and Number of refugees in Mali?
Your answer should be very brief. 1.22e+04. In the year 2001, what is the difference between the Number of refugees in Latin America(developing only) and Number of refugees in Germany?
Give a very brief answer. -8.69e+05. In the year 2001, what is the difference between the Number of refugees in Latin America(developing only) and Number of refugees in Kazakhstan?
Keep it short and to the point. 1.47e+04. In the year 2001, what is the difference between the Number of refugees of Latin America(developing only) and Number of refugees of Mali?
Provide a succinct answer. 2.58e+04. In the year 2001, what is the difference between the Number of refugees in Germany and Number of refugees in Kazakhstan?
Provide a succinct answer. 8.83e+05. In the year 2001, what is the difference between the Number of refugees of Germany and Number of refugees of Mali?
Offer a terse response. 8.95e+05. In the year 2001, what is the difference between the Number of refugees in Kazakhstan and Number of refugees in Mali?
Your answer should be very brief. 1.11e+04. In the year 2002, what is the difference between the Number of refugees of Latin America(developing only) and Number of refugees of Germany?
Give a very brief answer. -9.42e+05. In the year 2002, what is the difference between the Number of refugees of Latin America(developing only) and Number of refugees of Kazakhstan?
Make the answer very short. 1.73e+04. In the year 2002, what is the difference between the Number of refugees of Latin America(developing only) and Number of refugees of Mali?
Make the answer very short. 2.88e+04. In the year 2002, what is the difference between the Number of refugees in Germany and Number of refugees in Kazakhstan?
Make the answer very short. 9.59e+05. In the year 2002, what is the difference between the Number of refugees in Germany and Number of refugees in Mali?
Give a very brief answer. 9.71e+05. In the year 2002, what is the difference between the Number of refugees of Kazakhstan and Number of refugees of Mali?
Provide a short and direct response. 1.15e+04. In the year 2003, what is the difference between the Number of refugees in Latin America(developing only) and Number of refugees in Germany?
Your answer should be very brief. -9.25e+05. In the year 2003, what is the difference between the Number of refugees in Latin America(developing only) and Number of refugees in Kazakhstan?
Make the answer very short. 1.92e+04. In the year 2003, what is the difference between the Number of refugees of Latin America(developing only) and Number of refugees of Mali?
Give a very brief answer. 2.50e+04. In the year 2003, what is the difference between the Number of refugees of Germany and Number of refugees of Kazakhstan?
Provide a short and direct response. 9.45e+05. In the year 2003, what is the difference between the Number of refugees of Germany and Number of refugees of Mali?
Keep it short and to the point. 9.50e+05. In the year 2003, what is the difference between the Number of refugees in Kazakhstan and Number of refugees in Mali?
Provide a succinct answer. 5822. In the year 2004, what is the difference between the Number of refugees in Latin America(developing only) and Number of refugees in Germany?
Give a very brief answer. -8.44e+05. In the year 2004, what is the difference between the Number of refugees of Latin America(developing only) and Number of refugees of Kazakhstan?
Your answer should be very brief. 1.65e+04. In the year 2004, what is the difference between the Number of refugees of Latin America(developing only) and Number of refugees of Mali?
Offer a very short reply. 2.11e+04. In the year 2004, what is the difference between the Number of refugees in Germany and Number of refugees in Kazakhstan?
Offer a terse response. 8.61e+05. In the year 2004, what is the difference between the Number of refugees in Germany and Number of refugees in Mali?
Make the answer very short. 8.65e+05. In the year 2004, what is the difference between the Number of refugees of Kazakhstan and Number of refugees of Mali?
Your answer should be compact. 4588. In the year 2005, what is the difference between the Number of refugees of Latin America(developing only) and Number of refugees of Germany?
Offer a very short reply. -6.67e+05. In the year 2005, what is the difference between the Number of refugees in Latin America(developing only) and Number of refugees in Kazakhstan?
Provide a short and direct response. 2.61e+04. In the year 2005, what is the difference between the Number of refugees of Latin America(developing only) and Number of refugees of Mali?
Offer a very short reply. 2.21e+04. In the year 2005, what is the difference between the Number of refugees of Germany and Number of refugees of Kazakhstan?
Your response must be concise. 6.93e+05. In the year 2005, what is the difference between the Number of refugees of Germany and Number of refugees of Mali?
Offer a terse response. 6.89e+05. In the year 2005, what is the difference between the Number of refugees in Kazakhstan and Number of refugees in Mali?
Offer a very short reply. -3968. In the year 2006, what is the difference between the Number of refugees in Latin America(developing only) and Number of refugees in Germany?
Provide a short and direct response. -5.70e+05. In the year 2006, what is the difference between the Number of refugees in Latin America(developing only) and Number of refugees in Kazakhstan?
Provide a succinct answer. 3.10e+04. In the year 2006, what is the difference between the Number of refugees in Latin America(developing only) and Number of refugees in Mali?
Your response must be concise. 2.49e+04. In the year 2006, what is the difference between the Number of refugees of Germany and Number of refugees of Kazakhstan?
Give a very brief answer. 6.01e+05. In the year 2006, what is the difference between the Number of refugees of Germany and Number of refugees of Mali?
Ensure brevity in your answer.  5.95e+05. In the year 2006, what is the difference between the Number of refugees in Kazakhstan and Number of refugees in Mali?
Give a very brief answer. -6173. What is the ratio of the Number of refugees in Latin America(developing only) in 1999 to that in 2000?
Make the answer very short. 1.68. What is the ratio of the Number of refugees in Germany in 1999 to that in 2000?
Make the answer very short. 1.08. What is the ratio of the Number of refugees in Kazakhstan in 1999 to that in 2000?
Ensure brevity in your answer.  0.72. What is the ratio of the Number of refugees in Mali in 1999 to that in 2000?
Give a very brief answer. 0.99. What is the ratio of the Number of refugees in Latin America(developing only) in 1999 to that in 2001?
Provide a short and direct response. 1.71. What is the ratio of the Number of refugees in Germany in 1999 to that in 2001?
Offer a very short reply. 1.08. What is the ratio of the Number of refugees of Kazakhstan in 1999 to that in 2001?
Ensure brevity in your answer.  0.76. What is the ratio of the Number of refugees of Mali in 1999 to that in 2001?
Offer a terse response. 0.98. What is the ratio of the Number of refugees in Latin America(developing only) in 1999 to that in 2002?
Provide a succinct answer. 1.54. What is the ratio of the Number of refugees in Germany in 1999 to that in 2002?
Keep it short and to the point. 1. What is the ratio of the Number of refugees of Kazakhstan in 1999 to that in 2002?
Make the answer very short. 0.72. What is the ratio of the Number of refugees of Mali in 1999 to that in 2002?
Ensure brevity in your answer.  0.91. What is the ratio of the Number of refugees in Latin America(developing only) in 1999 to that in 2003?
Ensure brevity in your answer.  1.67. What is the ratio of the Number of refugees in Germany in 1999 to that in 2003?
Provide a succinct answer. 1.02. What is the ratio of the Number of refugees of Kazakhstan in 1999 to that in 2003?
Keep it short and to the point. 0.93. What is the ratio of the Number of refugees of Mali in 1999 to that in 2003?
Offer a terse response. 0.83. What is the ratio of the Number of refugees in Latin America(developing only) in 1999 to that in 2004?
Your answer should be compact. 1.81. What is the ratio of the Number of refugees of Germany in 1999 to that in 2004?
Your answer should be compact. 1.11. What is the ratio of the Number of refugees in Kazakhstan in 1999 to that in 2004?
Keep it short and to the point. 0.93. What is the ratio of the Number of refugees of Mali in 1999 to that in 2004?
Your answer should be compact. 0.74. What is the ratio of the Number of refugees of Latin America(developing only) in 1999 to that in 2005?
Ensure brevity in your answer.  1.75. What is the ratio of the Number of refugees in Germany in 1999 to that in 2005?
Provide a short and direct response. 1.39. What is the ratio of the Number of refugees of Kazakhstan in 1999 to that in 2005?
Provide a short and direct response. 2.04. What is the ratio of the Number of refugees of Mali in 1999 to that in 2005?
Your response must be concise. 0.74. What is the ratio of the Number of refugees in Latin America(developing only) in 1999 to that in 2006?
Offer a terse response. 1.65. What is the ratio of the Number of refugees of Germany in 1999 to that in 2006?
Your response must be concise. 1.61. What is the ratio of the Number of refugees in Kazakhstan in 1999 to that in 2006?
Your answer should be compact. 3.35. What is the ratio of the Number of refugees of Mali in 1999 to that in 2006?
Keep it short and to the point. 0.78. What is the ratio of the Number of refugees of Latin America(developing only) in 2000 to that in 2001?
Provide a succinct answer. 1.02. What is the ratio of the Number of refugees in Germany in 2000 to that in 2001?
Your answer should be very brief. 1. What is the ratio of the Number of refugees of Kazakhstan in 2000 to that in 2001?
Provide a short and direct response. 1.05. What is the ratio of the Number of refugees in Mali in 2000 to that in 2001?
Give a very brief answer. 1. What is the ratio of the Number of refugees in Latin America(developing only) in 2000 to that in 2002?
Your response must be concise. 0.92. What is the ratio of the Number of refugees in Germany in 2000 to that in 2002?
Make the answer very short. 0.92. What is the ratio of the Number of refugees in Mali in 2000 to that in 2002?
Offer a very short reply. 0.92. What is the ratio of the Number of refugees in Latin America(developing only) in 2000 to that in 2003?
Offer a terse response. 0.99. What is the ratio of the Number of refugees of Germany in 2000 to that in 2003?
Ensure brevity in your answer.  0.94. What is the ratio of the Number of refugees in Kazakhstan in 2000 to that in 2003?
Your answer should be compact. 1.3. What is the ratio of the Number of refugees in Mali in 2000 to that in 2003?
Provide a succinct answer. 0.84. What is the ratio of the Number of refugees in Latin America(developing only) in 2000 to that in 2004?
Your answer should be compact. 1.07. What is the ratio of the Number of refugees of Germany in 2000 to that in 2004?
Provide a succinct answer. 1.03. What is the ratio of the Number of refugees of Kazakhstan in 2000 to that in 2004?
Your answer should be compact. 1.3. What is the ratio of the Number of refugees of Mali in 2000 to that in 2004?
Ensure brevity in your answer.  0.75. What is the ratio of the Number of refugees of Latin America(developing only) in 2000 to that in 2005?
Your answer should be very brief. 1.04. What is the ratio of the Number of refugees of Germany in 2000 to that in 2005?
Make the answer very short. 1.29. What is the ratio of the Number of refugees of Kazakhstan in 2000 to that in 2005?
Provide a short and direct response. 2.83. What is the ratio of the Number of refugees in Mali in 2000 to that in 2005?
Keep it short and to the point. 0.75. What is the ratio of the Number of refugees in Latin America(developing only) in 2000 to that in 2006?
Ensure brevity in your answer.  0.98. What is the ratio of the Number of refugees of Germany in 2000 to that in 2006?
Your answer should be very brief. 1.5. What is the ratio of the Number of refugees of Kazakhstan in 2000 to that in 2006?
Offer a very short reply. 4.66. What is the ratio of the Number of refugees in Mali in 2000 to that in 2006?
Provide a short and direct response. 0.79. What is the ratio of the Number of refugees of Latin America(developing only) in 2001 to that in 2002?
Your response must be concise. 0.9. What is the ratio of the Number of refugees in Germany in 2001 to that in 2002?
Offer a terse response. 0.92. What is the ratio of the Number of refugees of Kazakhstan in 2001 to that in 2002?
Ensure brevity in your answer.  0.95. What is the ratio of the Number of refugees in Mali in 2001 to that in 2002?
Ensure brevity in your answer.  0.93. What is the ratio of the Number of refugees of Latin America(developing only) in 2001 to that in 2003?
Ensure brevity in your answer.  0.98. What is the ratio of the Number of refugees in Germany in 2001 to that in 2003?
Your response must be concise. 0.94. What is the ratio of the Number of refugees of Kazakhstan in 2001 to that in 2003?
Keep it short and to the point. 1.23. What is the ratio of the Number of refugees in Mali in 2001 to that in 2003?
Provide a succinct answer. 0.84. What is the ratio of the Number of refugees of Latin America(developing only) in 2001 to that in 2004?
Your answer should be very brief. 1.06. What is the ratio of the Number of refugees of Germany in 2001 to that in 2004?
Your answer should be compact. 1.03. What is the ratio of the Number of refugees in Kazakhstan in 2001 to that in 2004?
Your answer should be compact. 1.23. What is the ratio of the Number of refugees of Mali in 2001 to that in 2004?
Provide a short and direct response. 0.75. What is the ratio of the Number of refugees in Latin America(developing only) in 2001 to that in 2005?
Offer a very short reply. 1.03. What is the ratio of the Number of refugees of Germany in 2001 to that in 2005?
Provide a short and direct response. 1.29. What is the ratio of the Number of refugees in Kazakhstan in 2001 to that in 2005?
Ensure brevity in your answer.  2.69. What is the ratio of the Number of refugees of Mali in 2001 to that in 2005?
Your answer should be very brief. 0.75. What is the ratio of the Number of refugees in Latin America(developing only) in 2001 to that in 2006?
Offer a terse response. 0.96. What is the ratio of the Number of refugees in Germany in 2001 to that in 2006?
Offer a terse response. 1.49. What is the ratio of the Number of refugees in Kazakhstan in 2001 to that in 2006?
Offer a terse response. 4.43. What is the ratio of the Number of refugees of Mali in 2001 to that in 2006?
Provide a short and direct response. 0.8. What is the ratio of the Number of refugees of Latin America(developing only) in 2002 to that in 2003?
Offer a terse response. 1.08. What is the ratio of the Number of refugees in Germany in 2002 to that in 2003?
Your answer should be very brief. 1.02. What is the ratio of the Number of refugees in Kazakhstan in 2002 to that in 2003?
Provide a short and direct response. 1.3. What is the ratio of the Number of refugees in Mali in 2002 to that in 2003?
Provide a short and direct response. 0.91. What is the ratio of the Number of refugees of Latin America(developing only) in 2002 to that in 2004?
Offer a terse response. 1.17. What is the ratio of the Number of refugees of Germany in 2002 to that in 2004?
Offer a very short reply. 1.12. What is the ratio of the Number of refugees in Kazakhstan in 2002 to that in 2004?
Your answer should be very brief. 1.3. What is the ratio of the Number of refugees of Mali in 2002 to that in 2004?
Your response must be concise. 0.81. What is the ratio of the Number of refugees in Latin America(developing only) in 2002 to that in 2005?
Provide a succinct answer. 1.14. What is the ratio of the Number of refugees in Kazakhstan in 2002 to that in 2005?
Your answer should be very brief. 2.84. What is the ratio of the Number of refugees in Mali in 2002 to that in 2005?
Ensure brevity in your answer.  0.81. What is the ratio of the Number of refugees of Latin America(developing only) in 2002 to that in 2006?
Provide a short and direct response. 1.07. What is the ratio of the Number of refugees of Germany in 2002 to that in 2006?
Your response must be concise. 1.62. What is the ratio of the Number of refugees of Kazakhstan in 2002 to that in 2006?
Ensure brevity in your answer.  4.67. What is the ratio of the Number of refugees of Mali in 2002 to that in 2006?
Make the answer very short. 0.86. What is the ratio of the Number of refugees of Latin America(developing only) in 2003 to that in 2004?
Make the answer very short. 1.08. What is the ratio of the Number of refugees in Germany in 2003 to that in 2004?
Ensure brevity in your answer.  1.1. What is the ratio of the Number of refugees in Mali in 2003 to that in 2004?
Give a very brief answer. 0.89. What is the ratio of the Number of refugees of Latin America(developing only) in 2003 to that in 2005?
Provide a short and direct response. 1.05. What is the ratio of the Number of refugees in Germany in 2003 to that in 2005?
Provide a short and direct response. 1.37. What is the ratio of the Number of refugees of Kazakhstan in 2003 to that in 2005?
Your response must be concise. 2.18. What is the ratio of the Number of refugees in Mali in 2003 to that in 2005?
Ensure brevity in your answer.  0.89. What is the ratio of the Number of refugees of Latin America(developing only) in 2003 to that in 2006?
Make the answer very short. 0.99. What is the ratio of the Number of refugees of Germany in 2003 to that in 2006?
Provide a short and direct response. 1.59. What is the ratio of the Number of refugees in Kazakhstan in 2003 to that in 2006?
Provide a succinct answer. 3.59. What is the ratio of the Number of refugees of Mali in 2003 to that in 2006?
Offer a terse response. 0.95. What is the ratio of the Number of refugees in Latin America(developing only) in 2004 to that in 2005?
Ensure brevity in your answer.  0.97. What is the ratio of the Number of refugees of Germany in 2004 to that in 2005?
Offer a terse response. 1.25. What is the ratio of the Number of refugees of Kazakhstan in 2004 to that in 2005?
Your answer should be very brief. 2.18. What is the ratio of the Number of refugees in Latin America(developing only) in 2004 to that in 2006?
Provide a short and direct response. 0.91. What is the ratio of the Number of refugees in Germany in 2004 to that in 2006?
Offer a terse response. 1.45. What is the ratio of the Number of refugees of Kazakhstan in 2004 to that in 2006?
Provide a succinct answer. 3.59. What is the ratio of the Number of refugees of Mali in 2004 to that in 2006?
Offer a terse response. 1.06. What is the ratio of the Number of refugees in Latin America(developing only) in 2005 to that in 2006?
Give a very brief answer. 0.94. What is the ratio of the Number of refugees in Germany in 2005 to that in 2006?
Your answer should be compact. 1.16. What is the ratio of the Number of refugees of Kazakhstan in 2005 to that in 2006?
Offer a terse response. 1.65. What is the ratio of the Number of refugees of Mali in 2005 to that in 2006?
Give a very brief answer. 1.06. What is the difference between the highest and the second highest Number of refugees of Latin America(developing only)?
Keep it short and to the point. 2.06e+04. What is the difference between the highest and the second highest Number of refugees in Germany?
Offer a very short reply. 4500. What is the difference between the highest and the second highest Number of refugees of Mali?
Give a very brief answer. 23. What is the difference between the highest and the lowest Number of refugees in Latin America(developing only)?
Keep it short and to the point. 2.61e+04. What is the difference between the highest and the lowest Number of refugees in Germany?
Ensure brevity in your answer.  3.75e+05. What is the difference between the highest and the lowest Number of refugees in Kazakhstan?
Your response must be concise. 1.62e+04. What is the difference between the highest and the lowest Number of refugees in Mali?
Offer a terse response. 2954. 